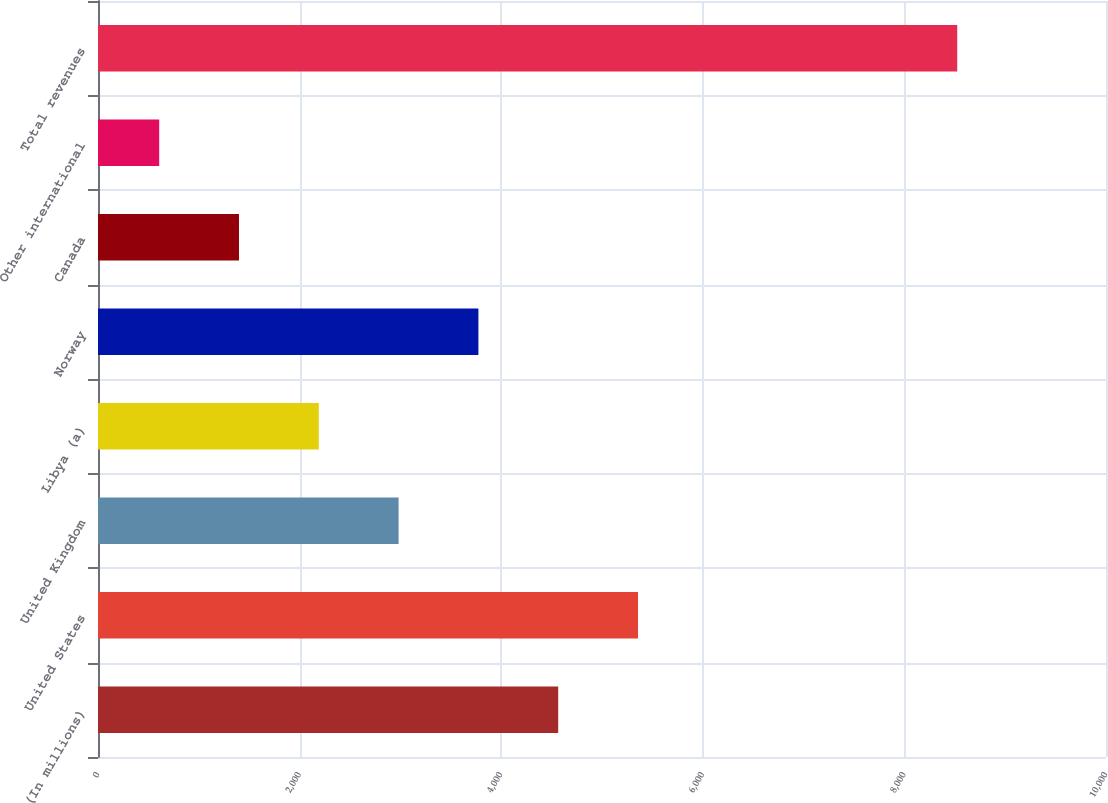<chart> <loc_0><loc_0><loc_500><loc_500><bar_chart><fcel>(In millions)<fcel>United States<fcel>United Kingdom<fcel>Libya (a)<fcel>Norway<fcel>Canada<fcel>Other international<fcel>Total revenues<nl><fcel>4565.5<fcel>5357.2<fcel>2982.1<fcel>2190.4<fcel>3773.8<fcel>1398.7<fcel>607<fcel>8524<nl></chart> 